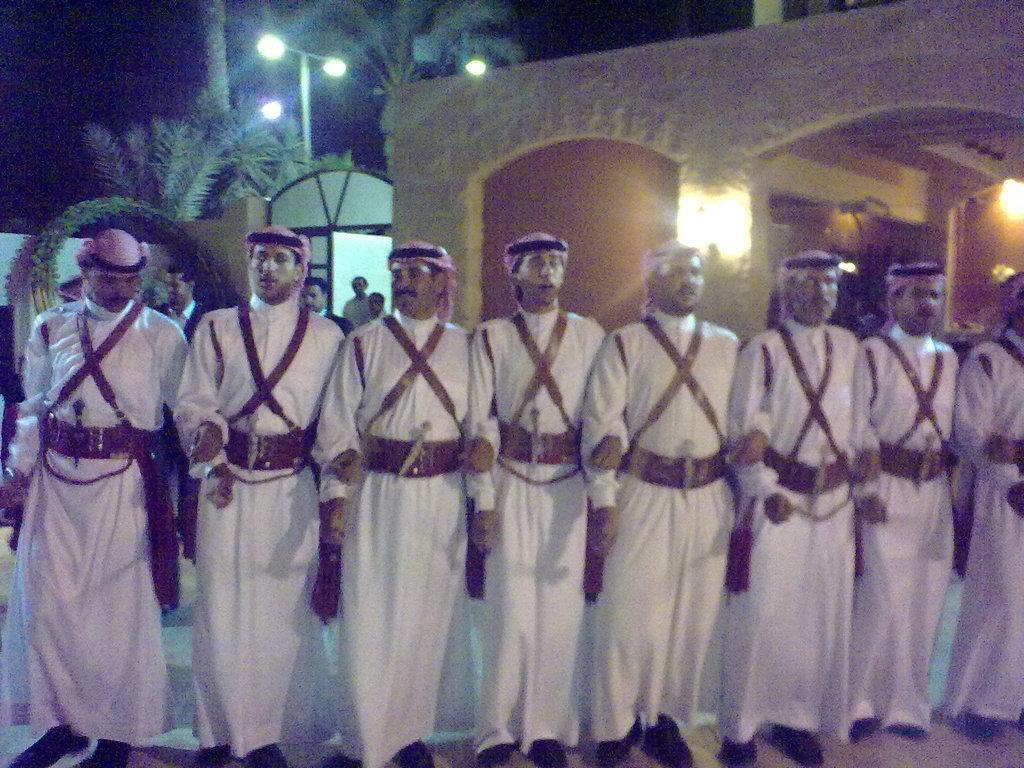In one or two sentences, can you explain what this image depicts? This picture describe about the group of men wearing white color Arabian traditional dress standing and singing. Behind we can see brown color arch and some coconut trees. 